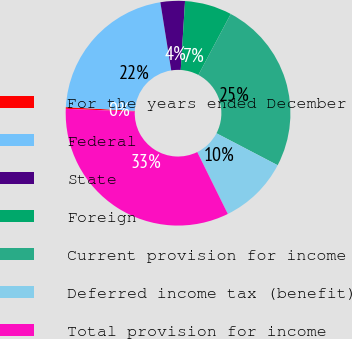<chart> <loc_0><loc_0><loc_500><loc_500><pie_chart><fcel>For the years ended December<fcel>Federal<fcel>State<fcel>Foreign<fcel>Current provision for income<fcel>Deferred income tax (benefit)<fcel>Total provision for income<nl><fcel>0.24%<fcel>21.62%<fcel>3.51%<fcel>6.78%<fcel>24.89%<fcel>10.04%<fcel>32.93%<nl></chart> 